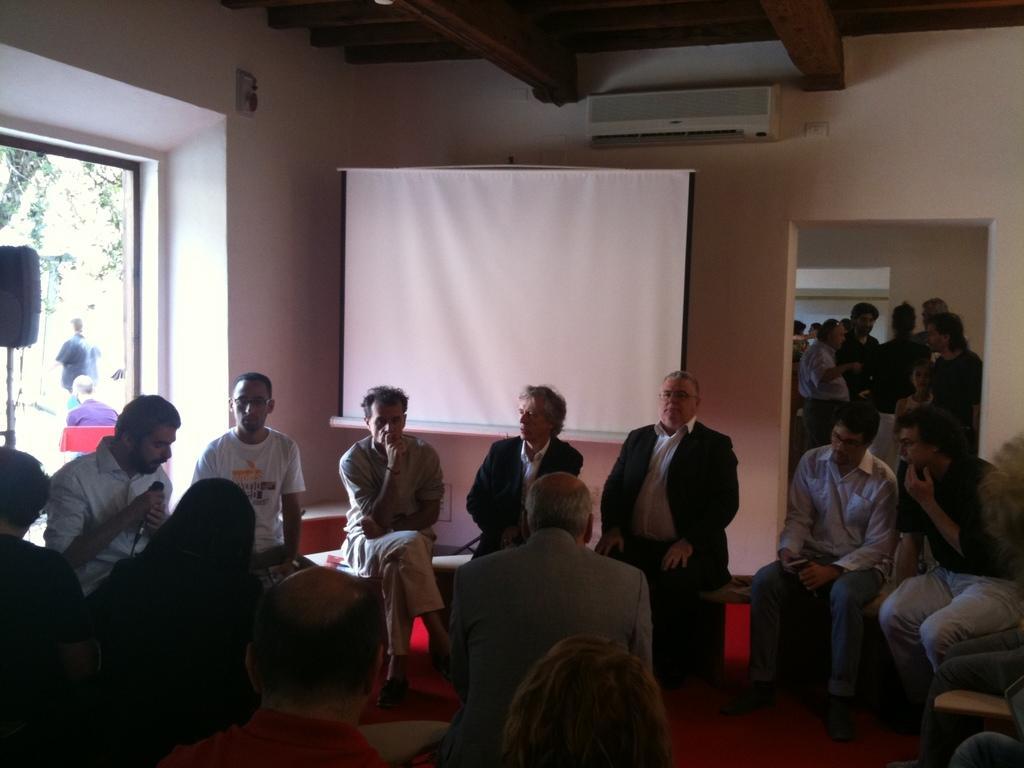Could you give a brief overview of what you see in this image? In this picture I can see people sitting the chairs. I can the projector screen. I can see air conditioner. I can see a few people standing on the right side. I can see the microphone. I can see glass window. 